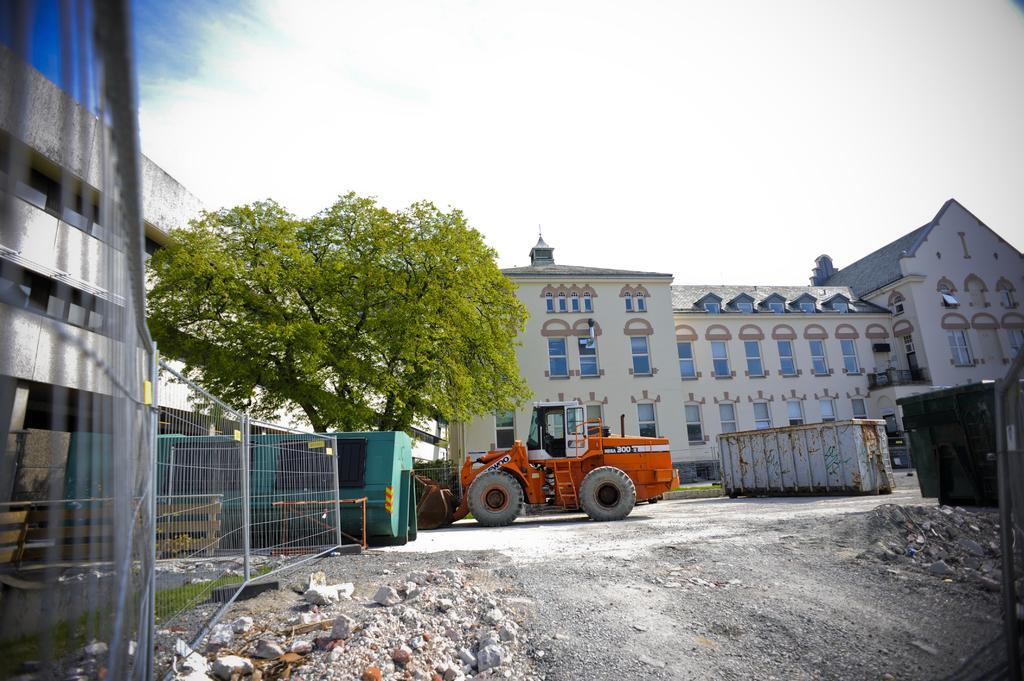Can you describe this image briefly? In this image we can see some buildings, windows, a tree, vehicle, fencing there are containers, rocks, also we can see the sky. 